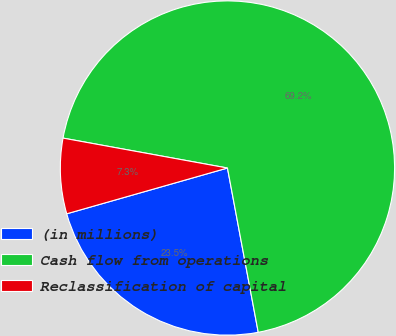Convert chart. <chart><loc_0><loc_0><loc_500><loc_500><pie_chart><fcel>(in millions)<fcel>Cash flow from operations<fcel>Reclassification of capital<nl><fcel>23.53%<fcel>69.18%<fcel>7.28%<nl></chart> 